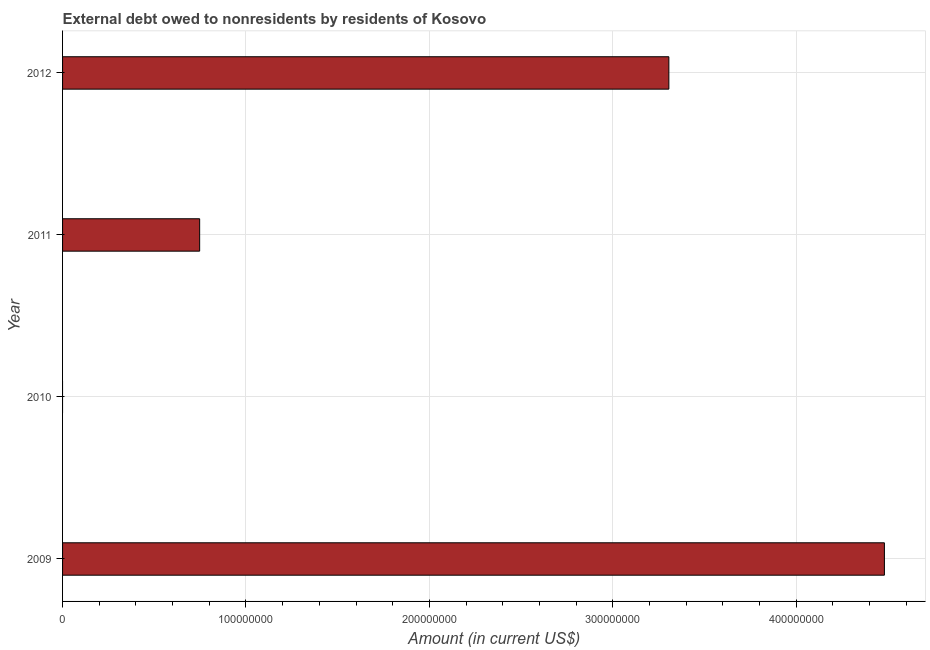What is the title of the graph?
Provide a short and direct response. External debt owed to nonresidents by residents of Kosovo. What is the debt in 2009?
Make the answer very short. 4.48e+08. Across all years, what is the maximum debt?
Make the answer very short. 4.48e+08. Across all years, what is the minimum debt?
Your response must be concise. 0. In which year was the debt maximum?
Your answer should be compact. 2009. What is the sum of the debt?
Keep it short and to the point. 8.53e+08. What is the difference between the debt in 2011 and 2012?
Your answer should be very brief. -2.56e+08. What is the average debt per year?
Your response must be concise. 2.13e+08. What is the median debt?
Keep it short and to the point. 2.03e+08. What is the ratio of the debt in 2009 to that in 2011?
Your answer should be compact. 6. Is the debt in 2011 less than that in 2012?
Make the answer very short. Yes. Is the difference between the debt in 2011 and 2012 greater than the difference between any two years?
Give a very brief answer. No. What is the difference between the highest and the second highest debt?
Provide a succinct answer. 1.18e+08. What is the difference between the highest and the lowest debt?
Your response must be concise. 4.48e+08. In how many years, is the debt greater than the average debt taken over all years?
Offer a terse response. 2. How many years are there in the graph?
Your response must be concise. 4. What is the difference between two consecutive major ticks on the X-axis?
Provide a short and direct response. 1.00e+08. Are the values on the major ticks of X-axis written in scientific E-notation?
Keep it short and to the point. No. What is the Amount (in current US$) of 2009?
Give a very brief answer. 4.48e+08. What is the Amount (in current US$) of 2011?
Your answer should be compact. 7.47e+07. What is the Amount (in current US$) of 2012?
Give a very brief answer. 3.31e+08. What is the difference between the Amount (in current US$) in 2009 and 2011?
Your response must be concise. 3.73e+08. What is the difference between the Amount (in current US$) in 2009 and 2012?
Ensure brevity in your answer.  1.18e+08. What is the difference between the Amount (in current US$) in 2011 and 2012?
Keep it short and to the point. -2.56e+08. What is the ratio of the Amount (in current US$) in 2009 to that in 2011?
Give a very brief answer. 6. What is the ratio of the Amount (in current US$) in 2009 to that in 2012?
Provide a short and direct response. 1.36. What is the ratio of the Amount (in current US$) in 2011 to that in 2012?
Your answer should be very brief. 0.23. 